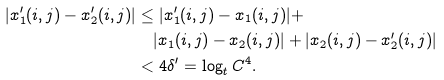<formula> <loc_0><loc_0><loc_500><loc_500>| x _ { 1 } ^ { \prime } ( i , j ) - x _ { 2 } ^ { \prime } ( i , j ) | & \leq | x _ { 1 } ^ { \prime } ( i , j ) - x _ { 1 } ( i , j ) | + \\ & \quad | x _ { 1 } ( i , j ) - x _ { 2 } ( i , j ) | + | x _ { 2 } ( i , j ) - x _ { 2 } ^ { \prime } ( i , j ) | \\ & < 4 \delta ^ { \prime } = \log _ { t } C ^ { 4 } .</formula> 